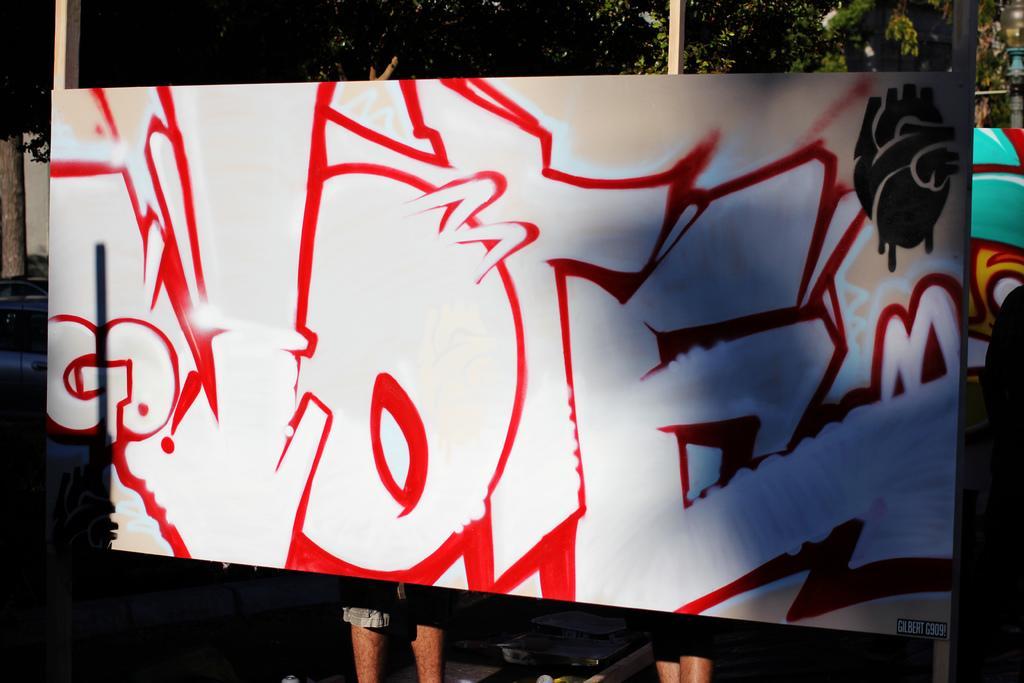In one or two sentences, can you explain what this image depicts? In this image I can see a board and on it I can see painting. I can see colour of this painting is black, red and white. In the background I can see few trees and here I can see legs of people. 